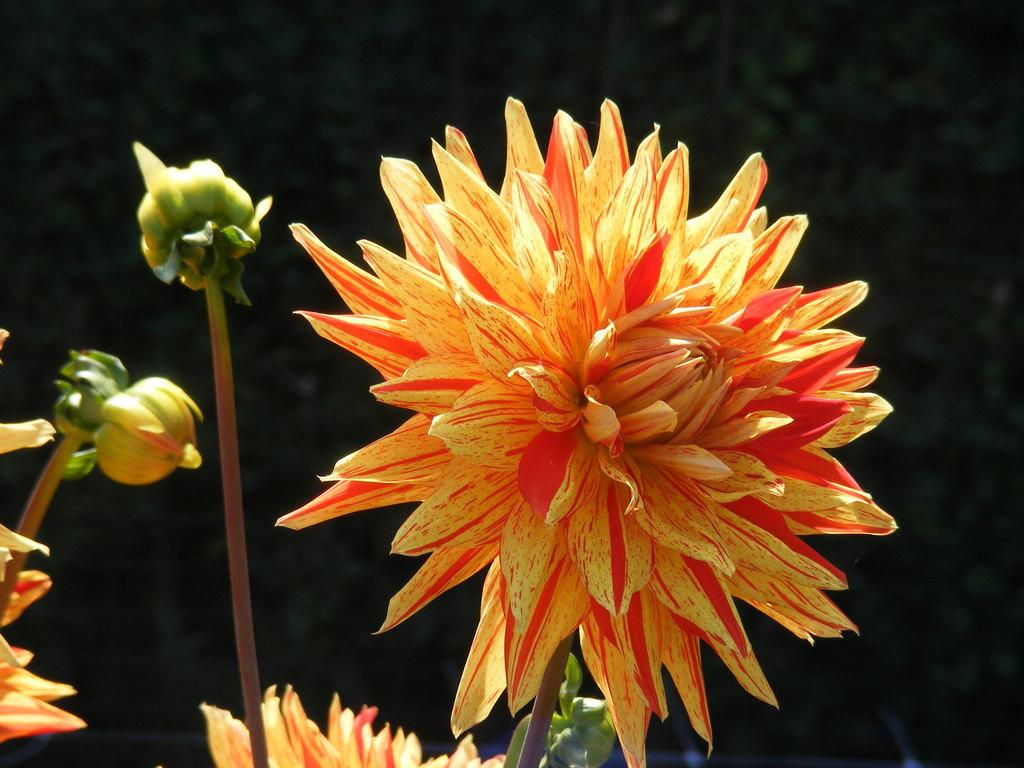What type of flora can be seen in the image? There are flowers and a plant in the image. What colors are the flowers? The flowers are yellow and orange in color. What colors are the plant? The plant is brown and green in color. What colors are the background of the image? The background of the image is black and green in color. How many prisoners are visible in the image? There are no prisoners present in the image; it features flowers and a plant. What type of brush is used to paint the plant in the image? There is no indication that the plant in the image was painted, and therefore no specific brush can be identified. 